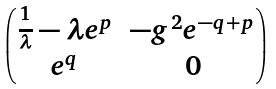<formula> <loc_0><loc_0><loc_500><loc_500>\begin{pmatrix} \frac { 1 } { \lambda } - \lambda e ^ { p } & - g ^ { 2 } e ^ { - q + p } \\ e ^ { q } & 0 \end{pmatrix}</formula> 